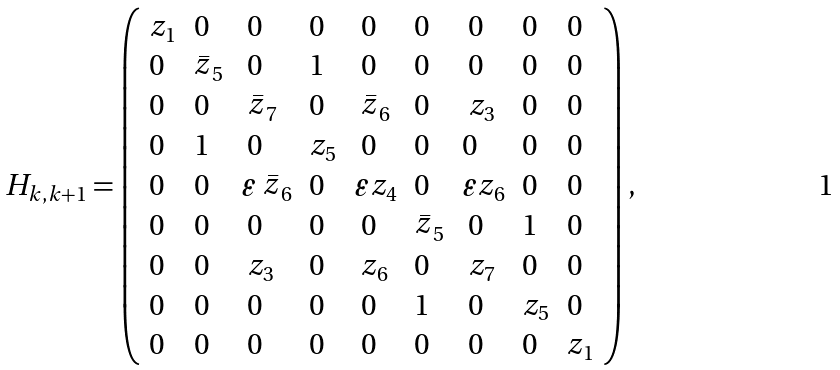<formula> <loc_0><loc_0><loc_500><loc_500>H _ { k , k + 1 } = \left ( \begin{array} { l l l l l l l l l } z _ { 1 } & 0 & \ 0 & 0 & \ 0 & 0 & \ 0 & 0 & 0 \\ 0 & \stackrel { \_ } { z } _ { 5 } & \ 0 & 1 & \ 0 & 0 & \ 0 & 0 & 0 \\ 0 & 0 & \ \stackrel { \_ } { z } _ { 7 } & 0 & \ \stackrel { \_ } { z } _ { 6 } & 0 & \ z _ { 3 } & 0 & 0 \\ 0 & 1 & \ 0 & z _ { 5 } & \ 0 & 0 & 0 & 0 & 0 \\ 0 & 0 & \varepsilon \stackrel { \_ } { z } _ { 6 } & 0 & \varepsilon z _ { 4 } & 0 & \varepsilon z _ { 6 } & 0 & 0 \\ 0 & 0 & \ 0 & 0 & \ 0 & \stackrel { \_ } { z } _ { 5 } & \ 0 & 1 & 0 \\ 0 & 0 & \ z _ { 3 } & 0 & \ z _ { 6 } & 0 & \ z _ { 7 } & 0 & 0 \\ 0 & 0 & \ 0 & 0 & \ 0 & 1 & \ 0 & z _ { 5 } & 0 \\ 0 & 0 & \ 0 & 0 & \ 0 & 0 & \ 0 & 0 & z _ { 1 } \end{array} \right ) ,</formula> 